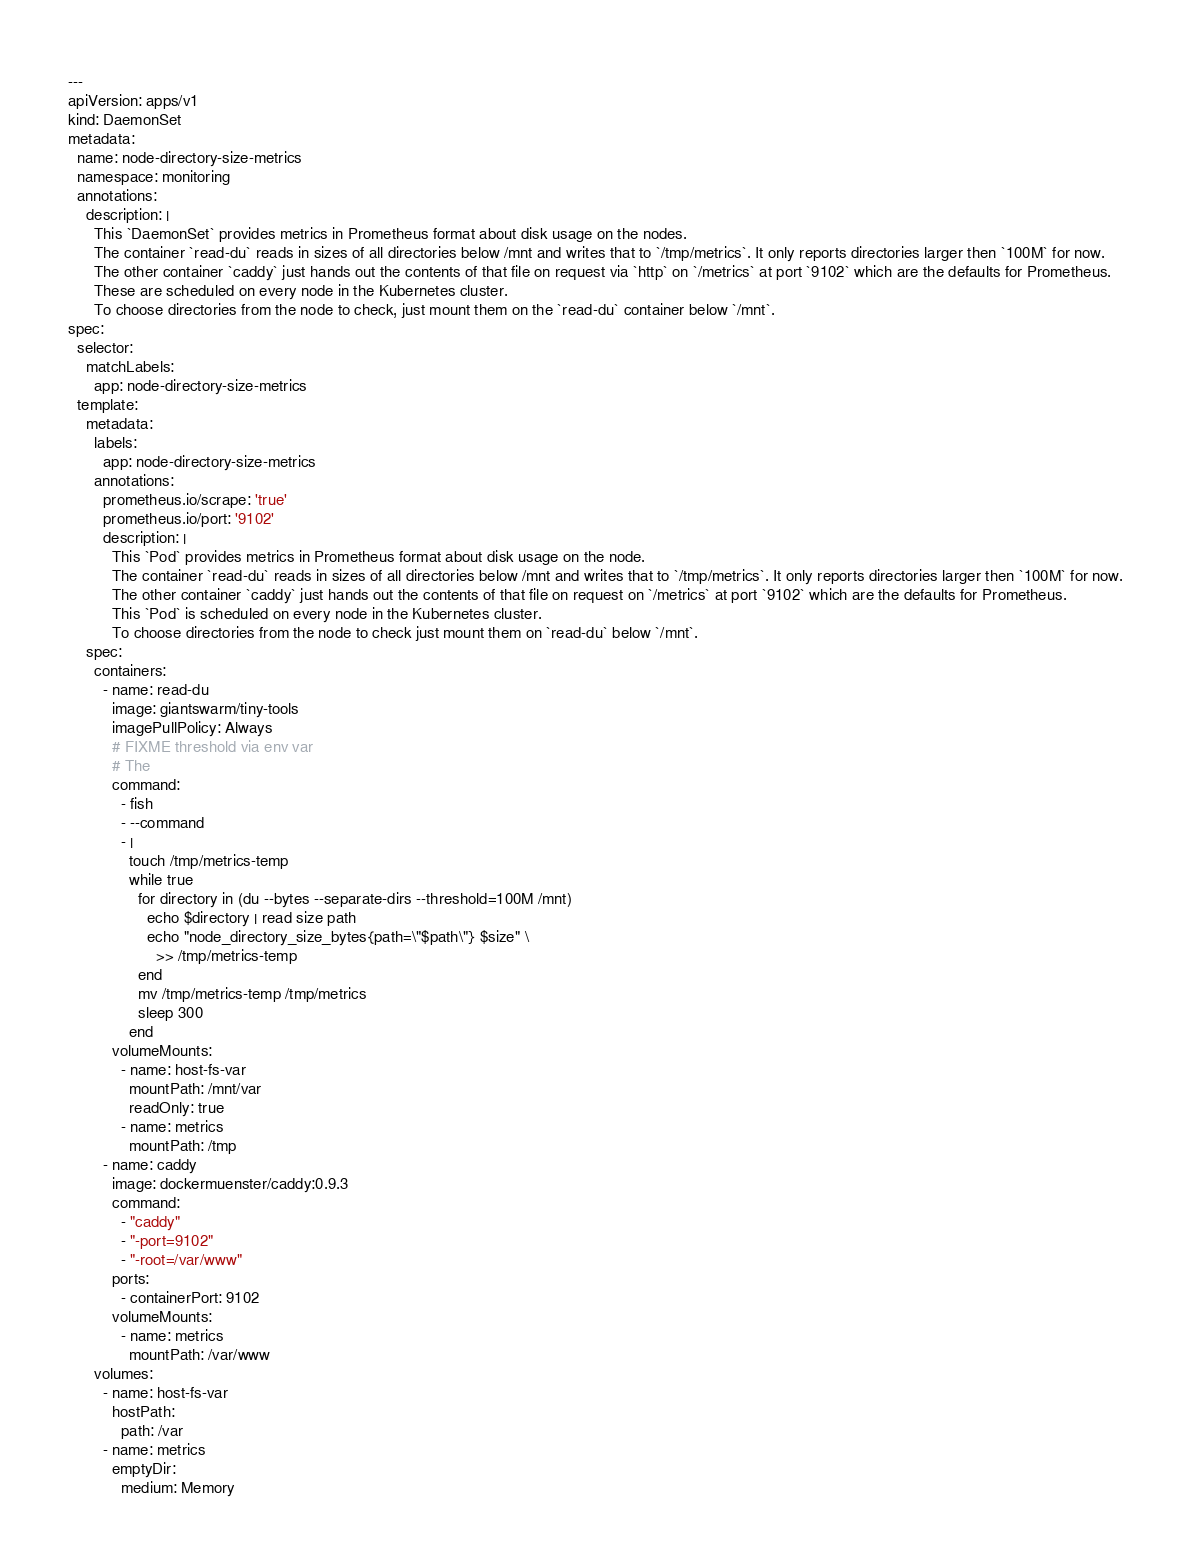Convert code to text. <code><loc_0><loc_0><loc_500><loc_500><_YAML_>---
apiVersion: apps/v1
kind: DaemonSet
metadata:
  name: node-directory-size-metrics
  namespace: monitoring
  annotations:
    description: |
      This `DaemonSet` provides metrics in Prometheus format about disk usage on the nodes.
      The container `read-du` reads in sizes of all directories below /mnt and writes that to `/tmp/metrics`. It only reports directories larger then `100M` for now.
      The other container `caddy` just hands out the contents of that file on request via `http` on `/metrics` at port `9102` which are the defaults for Prometheus.
      These are scheduled on every node in the Kubernetes cluster.
      To choose directories from the node to check, just mount them on the `read-du` container below `/mnt`.
spec:
  selector:
    matchLabels:
      app: node-directory-size-metrics
  template:
    metadata:
      labels:
        app: node-directory-size-metrics
      annotations:
        prometheus.io/scrape: 'true'
        prometheus.io/port: '9102'
        description: |
          This `Pod` provides metrics in Prometheus format about disk usage on the node.
          The container `read-du` reads in sizes of all directories below /mnt and writes that to `/tmp/metrics`. It only reports directories larger then `100M` for now.
          The other container `caddy` just hands out the contents of that file on request on `/metrics` at port `9102` which are the defaults for Prometheus.
          This `Pod` is scheduled on every node in the Kubernetes cluster.
          To choose directories from the node to check just mount them on `read-du` below `/mnt`.
    spec:
      containers:
        - name: read-du
          image: giantswarm/tiny-tools
          imagePullPolicy: Always
          # FIXME threshold via env var
          # The
          command:
            - fish
            - --command
            - |
              touch /tmp/metrics-temp
              while true
                for directory in (du --bytes --separate-dirs --threshold=100M /mnt)
                  echo $directory | read size path
                  echo "node_directory_size_bytes{path=\"$path\"} $size" \
                    >> /tmp/metrics-temp
                end
                mv /tmp/metrics-temp /tmp/metrics
                sleep 300
              end
          volumeMounts:
            - name: host-fs-var
              mountPath: /mnt/var
              readOnly: true
            - name: metrics
              mountPath: /tmp
        - name: caddy
          image: dockermuenster/caddy:0.9.3
          command:
            - "caddy"
            - "-port=9102"
            - "-root=/var/www"
          ports:
            - containerPort: 9102
          volumeMounts:
            - name: metrics
              mountPath: /var/www
      volumes:
        - name: host-fs-var
          hostPath:
            path: /var
        - name: metrics
          emptyDir:
            medium: Memory
</code> 